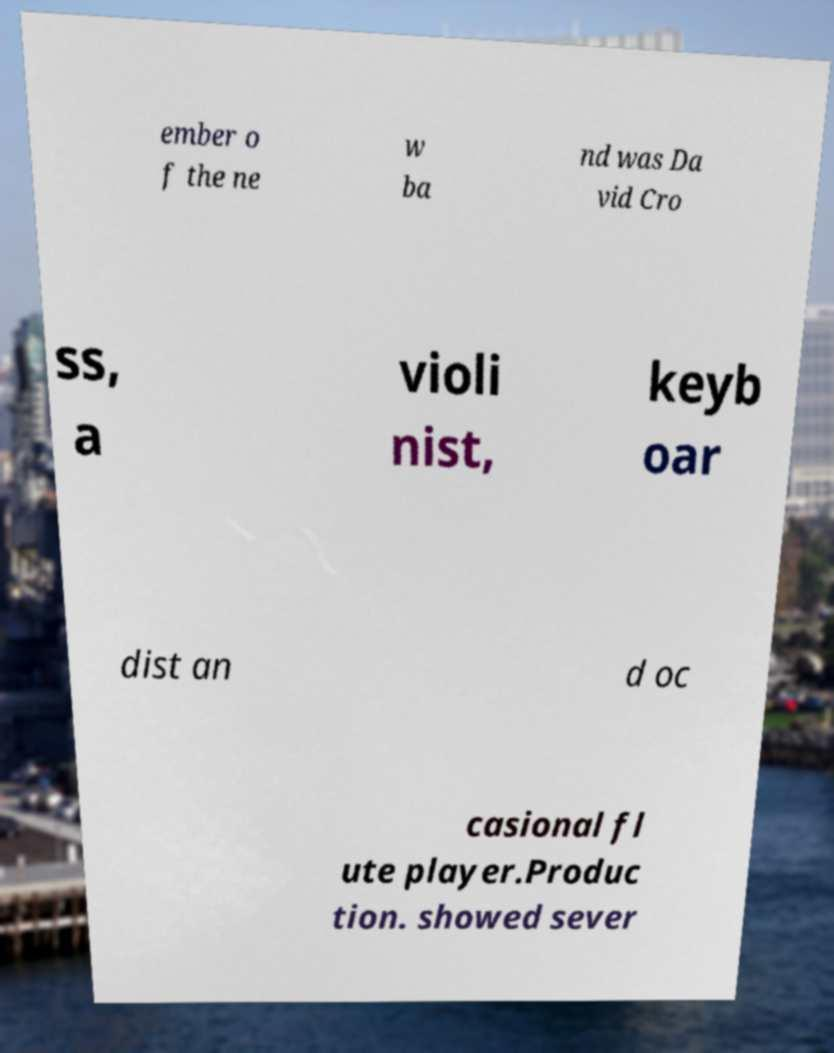What messages or text are displayed in this image? I need them in a readable, typed format. ember o f the ne w ba nd was Da vid Cro ss, a violi nist, keyb oar dist an d oc casional fl ute player.Produc tion. showed sever 